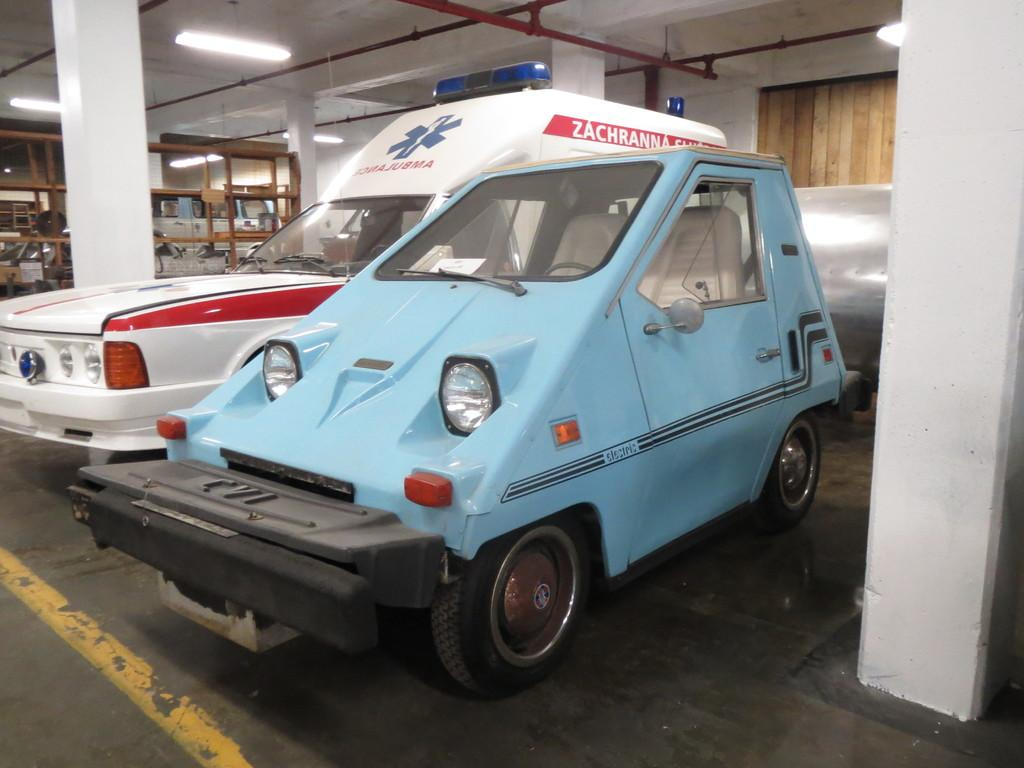What objects are on the floor in the image? There are vehicles on the floor in the image. What type of lighting is present in the image? There are tube lights on top in the image. What type of print can be seen on the vehicles in the image? There is no information about any prints on the vehicles in the image. 